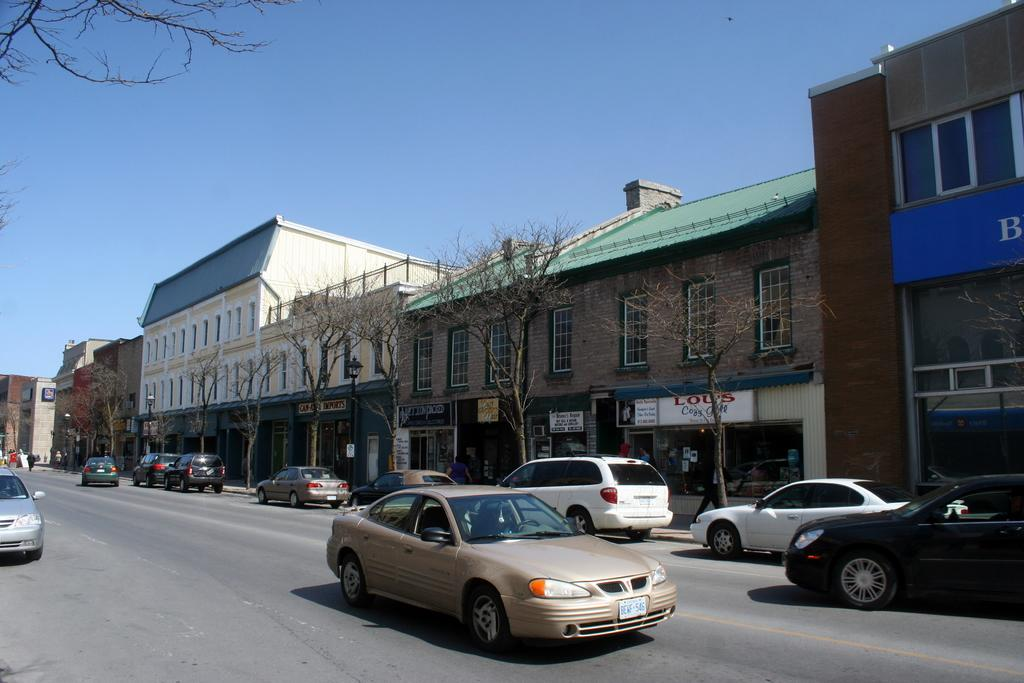What can be seen on the road in the image? There are vehicles on the road in the image. What type of natural elements are visible in the image? There are trees visible in the image. What type of man-made structures can be seen in the image? There are buildings in the image. How many girls are participating in the feast in the image? There is no feast or girls present in the image. What type of rock is visible in the image? There is no rock visible in the image. 